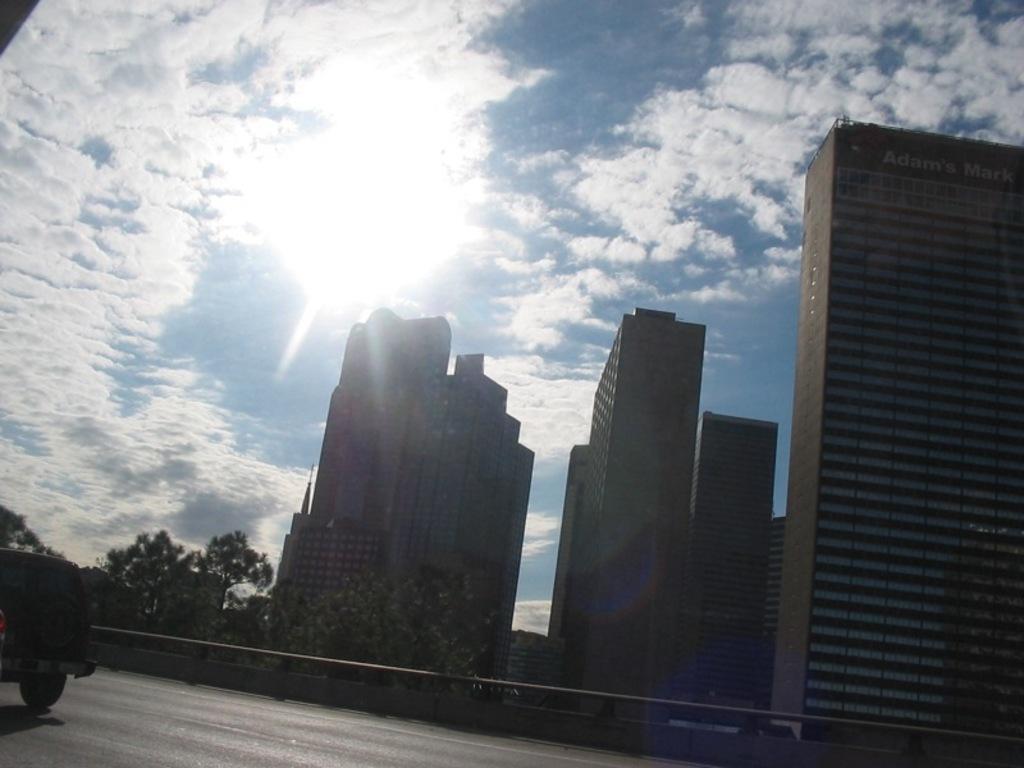In one or two sentences, can you explain what this image depicts? In the picture we can see a road on it, we can see a part of the vehicle and far away from it, we can see railing and behind it, we can see trees and tower buildings with many floors and behind it we can see a sky with clouds and sunshine. 